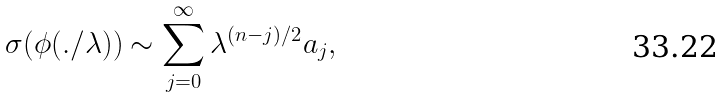<formula> <loc_0><loc_0><loc_500><loc_500>\sigma ( \phi ( . / \lambda ) ) \sim \sum _ { j = 0 } ^ { \infty } \lambda ^ { ( n - j ) / 2 } a _ { j } ,</formula> 